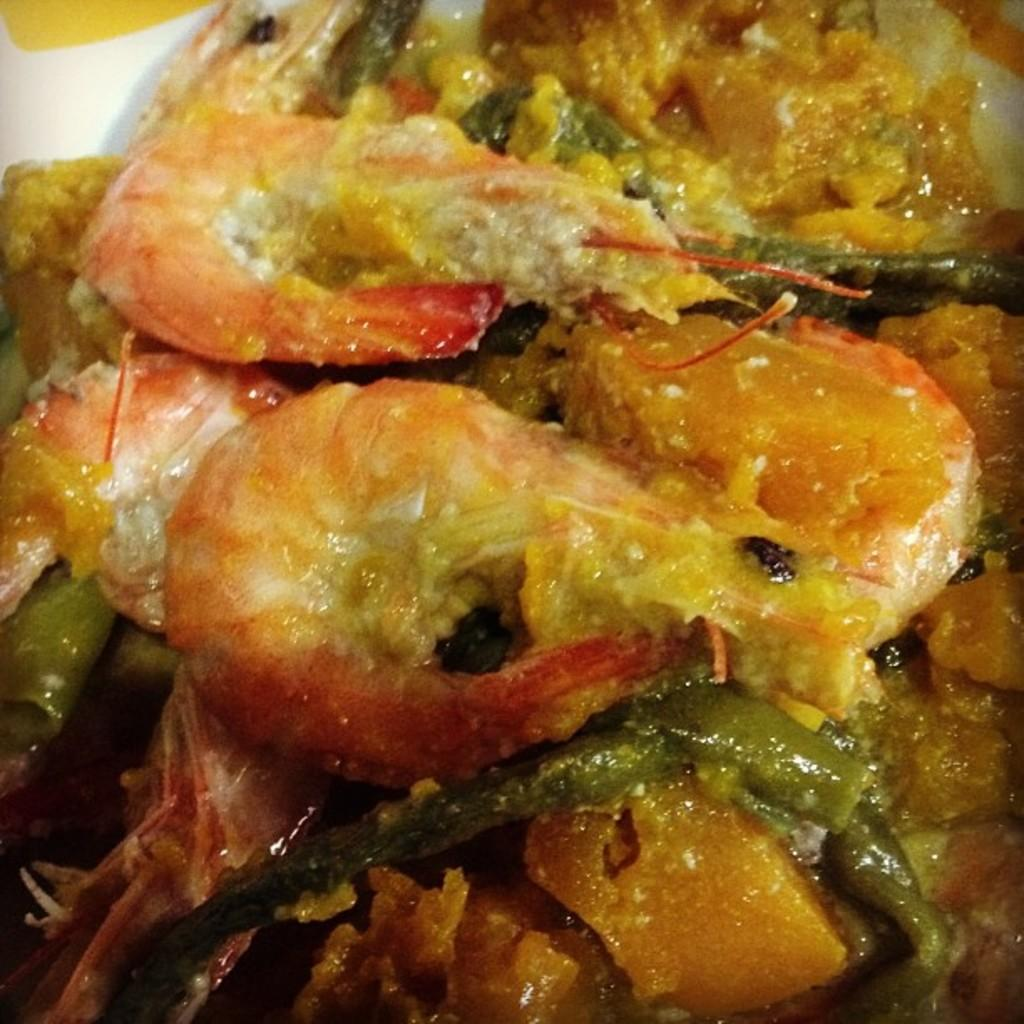What is placed on a plate in the image? There is food placed on a plate in the image. What type of mine is visible in the image? There is no mine present in the image; it features food placed on a plate. How many quilts are visible in the image? There are no quilts present in the image; it features food placed on a plate. 